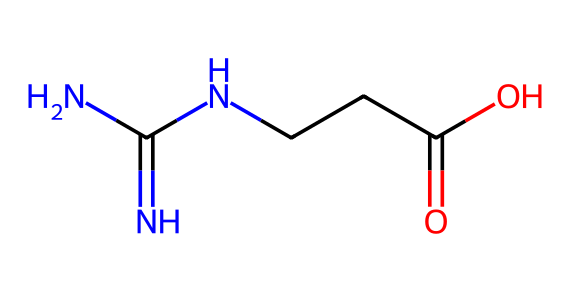What is the molecular formula of creatine? The SMILES representation suggests the presence of 4 carbon atoms, 9 hydrogen atoms, 3 nitrogen atoms, and 2 oxygen atoms. This implies the molecular formula is C4H9N3O2.
Answer: C4H9N3O2 How many nitrogen atoms are present in the structure? By analyzing the SMILES representation, we can identify three 'N' characters, indicating the presence of three nitrogen atoms in the structure.
Answer: 3 What type of functional group is present in creatine? The presence of a carboxyl group (–COOH) in the structure is identified from the 'C(=O)O' part of the SMILES representation. This group is characteristic of acids.
Answer: carboxylic acid Is creatine a protein or a peptide? Creatine is not a protein or a peptide; it is a simple biochemical compound that acts as a supplement. The structure doesn't have the peptide bonds typical of proteins.
Answer: no What is the structural feature that contributes to creatine's role in energy metabolism? The guanidino group (indicated by the NC(=N)N) is significant for energy metabolism as it helps in the formation of phosphocreatine, which is crucial for ATP regeneration during high-intensity exercise.
Answer: guanidino group 